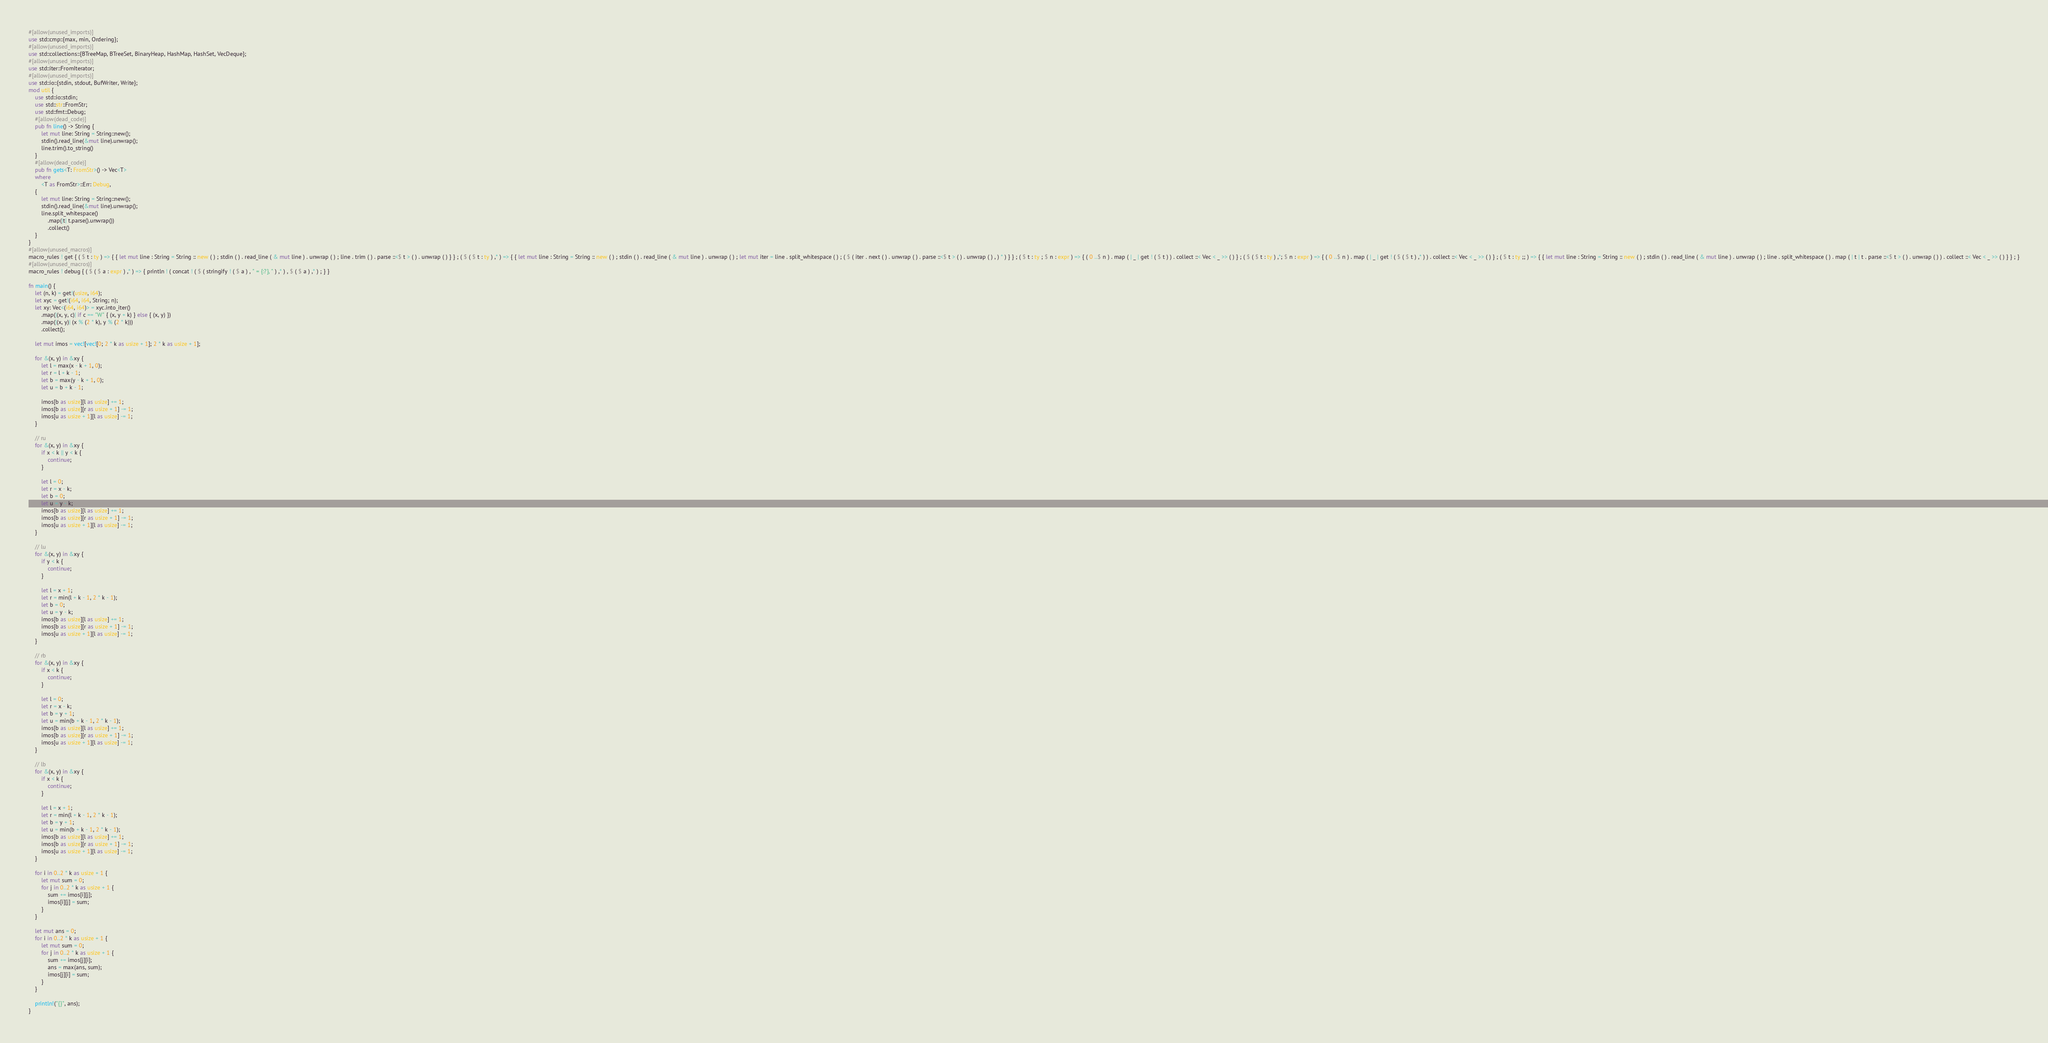Convert code to text. <code><loc_0><loc_0><loc_500><loc_500><_Rust_>#[allow(unused_imports)]
use std::cmp::{max, min, Ordering};
#[allow(unused_imports)]
use std::collections::{BTreeMap, BTreeSet, BinaryHeap, HashMap, HashSet, VecDeque};
#[allow(unused_imports)]
use std::iter::FromIterator;
#[allow(unused_imports)]
use std::io::{stdin, stdout, BufWriter, Write};
mod util {
    use std::io::stdin;
    use std::str::FromStr;
    use std::fmt::Debug;
    #[allow(dead_code)]
    pub fn line() -> String {
        let mut line: String = String::new();
        stdin().read_line(&mut line).unwrap();
        line.trim().to_string()
    }
    #[allow(dead_code)]
    pub fn gets<T: FromStr>() -> Vec<T>
    where
        <T as FromStr>::Err: Debug,
    {
        let mut line: String = String::new();
        stdin().read_line(&mut line).unwrap();
        line.split_whitespace()
            .map(|t| t.parse().unwrap())
            .collect()
    }
}
#[allow(unused_macros)]
macro_rules ! get { ( $ t : ty ) => { { let mut line : String = String :: new ( ) ; stdin ( ) . read_line ( & mut line ) . unwrap ( ) ; line . trim ( ) . parse ::<$ t > ( ) . unwrap ( ) } } ; ( $ ( $ t : ty ) ,* ) => { { let mut line : String = String :: new ( ) ; stdin ( ) . read_line ( & mut line ) . unwrap ( ) ; let mut iter = line . split_whitespace ( ) ; ( $ ( iter . next ( ) . unwrap ( ) . parse ::<$ t > ( ) . unwrap ( ) , ) * ) } } ; ( $ t : ty ; $ n : expr ) => { ( 0 ..$ n ) . map ( | _ | get ! ( $ t ) ) . collect ::< Vec < _ >> ( ) } ; ( $ ( $ t : ty ) ,*; $ n : expr ) => { ( 0 ..$ n ) . map ( | _ | get ! ( $ ( $ t ) ,* ) ) . collect ::< Vec < _ >> ( ) } ; ( $ t : ty ;; ) => { { let mut line : String = String :: new ( ) ; stdin ( ) . read_line ( & mut line ) . unwrap ( ) ; line . split_whitespace ( ) . map ( | t | t . parse ::<$ t > ( ) . unwrap ( ) ) . collect ::< Vec < _ >> ( ) } } ; }
#[allow(unused_macros)]
macro_rules ! debug { ( $ ( $ a : expr ) ,* ) => { println ! ( concat ! ( $ ( stringify ! ( $ a ) , " = {:?}, " ) ,* ) , $ ( $ a ) ,* ) ; } }

fn main() {
    let (n, k) = get!(usize, i64);
    let xyc = get!(i64, i64, String; n);
    let xy: Vec<(i64, i64)> = xyc.into_iter()
        .map(|(x, y, c)| if c == "W" { (x, y + k) } else { (x, y) })
        .map(|(x, y)| (x % (2 * k), y % (2 * k)))
        .collect();

    let mut imos = vec![vec![0; 2 * k as usize + 1]; 2 * k as usize + 1];

    for &(x, y) in &xy {
        let l = max(x - k + 1, 0);
        let r = l + k - 1;
        let b = max(y - k + 1, 0);
        let u = b + k - 1;

        imos[b as usize][l as usize] += 1;
        imos[b as usize][r as usize + 1] -= 1;
        imos[u as usize + 1][l as usize] -= 1;
    }

    // ru
    for &(x, y) in &xy {
        if x < k || y < k {
            continue;
        }

        let l = 0;
        let r = x - k;
        let b = 0;
        let u = y - k;
        imos[b as usize][l as usize] += 1;
        imos[b as usize][r as usize + 1] -= 1;
        imos[u as usize + 1][l as usize] -= 1;
    }

    // lu
    for &(x, y) in &xy {
        if y < k {
            continue;
        }

        let l = x + 1;
        let r = min(l + k - 1, 2 * k - 1);
        let b = 0;
        let u = y - k;
        imos[b as usize][l as usize] += 1;
        imos[b as usize][r as usize + 1] -= 1;
        imos[u as usize + 1][l as usize] -= 1;
    }

    // rb
    for &(x, y) in &xy {
        if x < k {
            continue;
        }

        let l = 0;
        let r = x - k;
        let b = y + 1;
        let u = min(b + k - 1, 2 * k - 1);
        imos[b as usize][l as usize] += 1;
        imos[b as usize][r as usize + 1] -= 1;
        imos[u as usize + 1][l as usize] -= 1;
    }

    // lb
    for &(x, y) in &xy {
        if x < k {
            continue;
        }

        let l = x + 1;
        let r = min(l + k - 1, 2 * k - 1);
        let b = y + 1;
        let u = min(b + k - 1, 2 * k - 1);
        imos[b as usize][l as usize] += 1;
        imos[b as usize][r as usize + 1] -= 1;
        imos[u as usize + 1][l as usize] -= 1;
    }

    for i in 0..2 * k as usize + 1 {
        let mut sum = 0;
        for j in 0..2 * k as usize + 1 {
            sum += imos[i][j];
            imos[i][j] = sum;
        }
    }

    let mut ans = 0;
    for i in 0..2 * k as usize + 1 {
        let mut sum = 0;
        for j in 0..2 * k as usize + 1 {
            sum += imos[j][i];
            ans = max(ans, sum);
            imos[j][i] = sum;
        }
    }

    println!("{}", ans);
}
</code> 